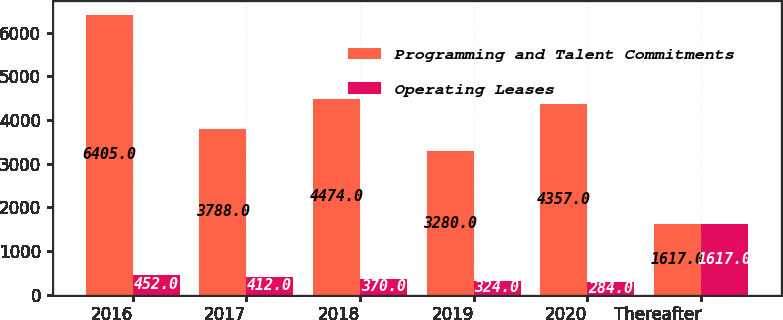Convert chart to OTSL. <chart><loc_0><loc_0><loc_500><loc_500><stacked_bar_chart><ecel><fcel>2016<fcel>2017<fcel>2018<fcel>2019<fcel>2020<fcel>Thereafter<nl><fcel>Programming and Talent Commitments<fcel>6405<fcel>3788<fcel>4474<fcel>3280<fcel>4357<fcel>1617<nl><fcel>Operating Leases<fcel>452<fcel>412<fcel>370<fcel>324<fcel>284<fcel>1617<nl></chart> 